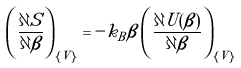Convert formula to latex. <formula><loc_0><loc_0><loc_500><loc_500>\left ( \frac { \partial S } { \partial \beta } \right ) _ { \{ V \} } = - k _ { B } \beta \left ( \frac { \partial U ( \beta ) } { \partial \beta } \right ) _ { \{ V \} }</formula> 